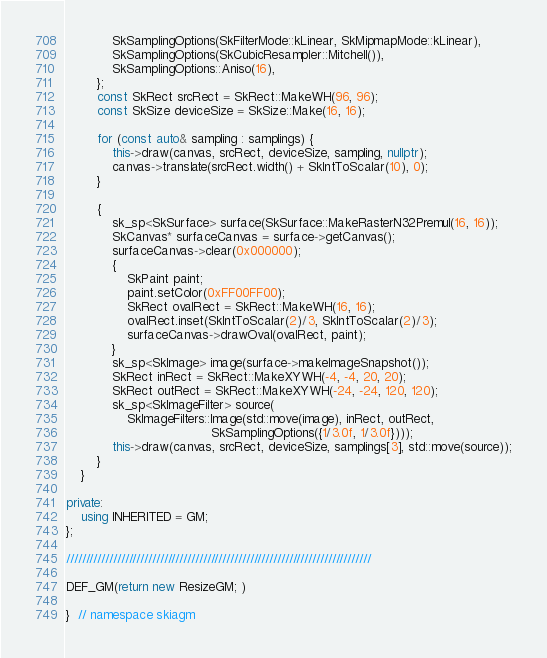Convert code to text. <code><loc_0><loc_0><loc_500><loc_500><_C++_>            SkSamplingOptions(SkFilterMode::kLinear, SkMipmapMode::kLinear),
            SkSamplingOptions(SkCubicResampler::Mitchell()),
            SkSamplingOptions::Aniso(16),
        };
        const SkRect srcRect = SkRect::MakeWH(96, 96);
        const SkSize deviceSize = SkSize::Make(16, 16);

        for (const auto& sampling : samplings) {
            this->draw(canvas, srcRect, deviceSize, sampling, nullptr);
            canvas->translate(srcRect.width() + SkIntToScalar(10), 0);
        }

        {
            sk_sp<SkSurface> surface(SkSurface::MakeRasterN32Premul(16, 16));
            SkCanvas* surfaceCanvas = surface->getCanvas();
            surfaceCanvas->clear(0x000000);
            {
                SkPaint paint;
                paint.setColor(0xFF00FF00);
                SkRect ovalRect = SkRect::MakeWH(16, 16);
                ovalRect.inset(SkIntToScalar(2)/3, SkIntToScalar(2)/3);
                surfaceCanvas->drawOval(ovalRect, paint);
            }
            sk_sp<SkImage> image(surface->makeImageSnapshot());
            SkRect inRect = SkRect::MakeXYWH(-4, -4, 20, 20);
            SkRect outRect = SkRect::MakeXYWH(-24, -24, 120, 120);
            sk_sp<SkImageFilter> source(
                SkImageFilters::Image(std::move(image), inRect, outRect,
                                      SkSamplingOptions({1/3.0f, 1/3.0f})));
            this->draw(canvas, srcRect, deviceSize, samplings[3], std::move(source));
        }
    }

private:
    using INHERITED = GM;
};

//////////////////////////////////////////////////////////////////////////////

DEF_GM(return new ResizeGM; )

}  // namespace skiagm
</code> 